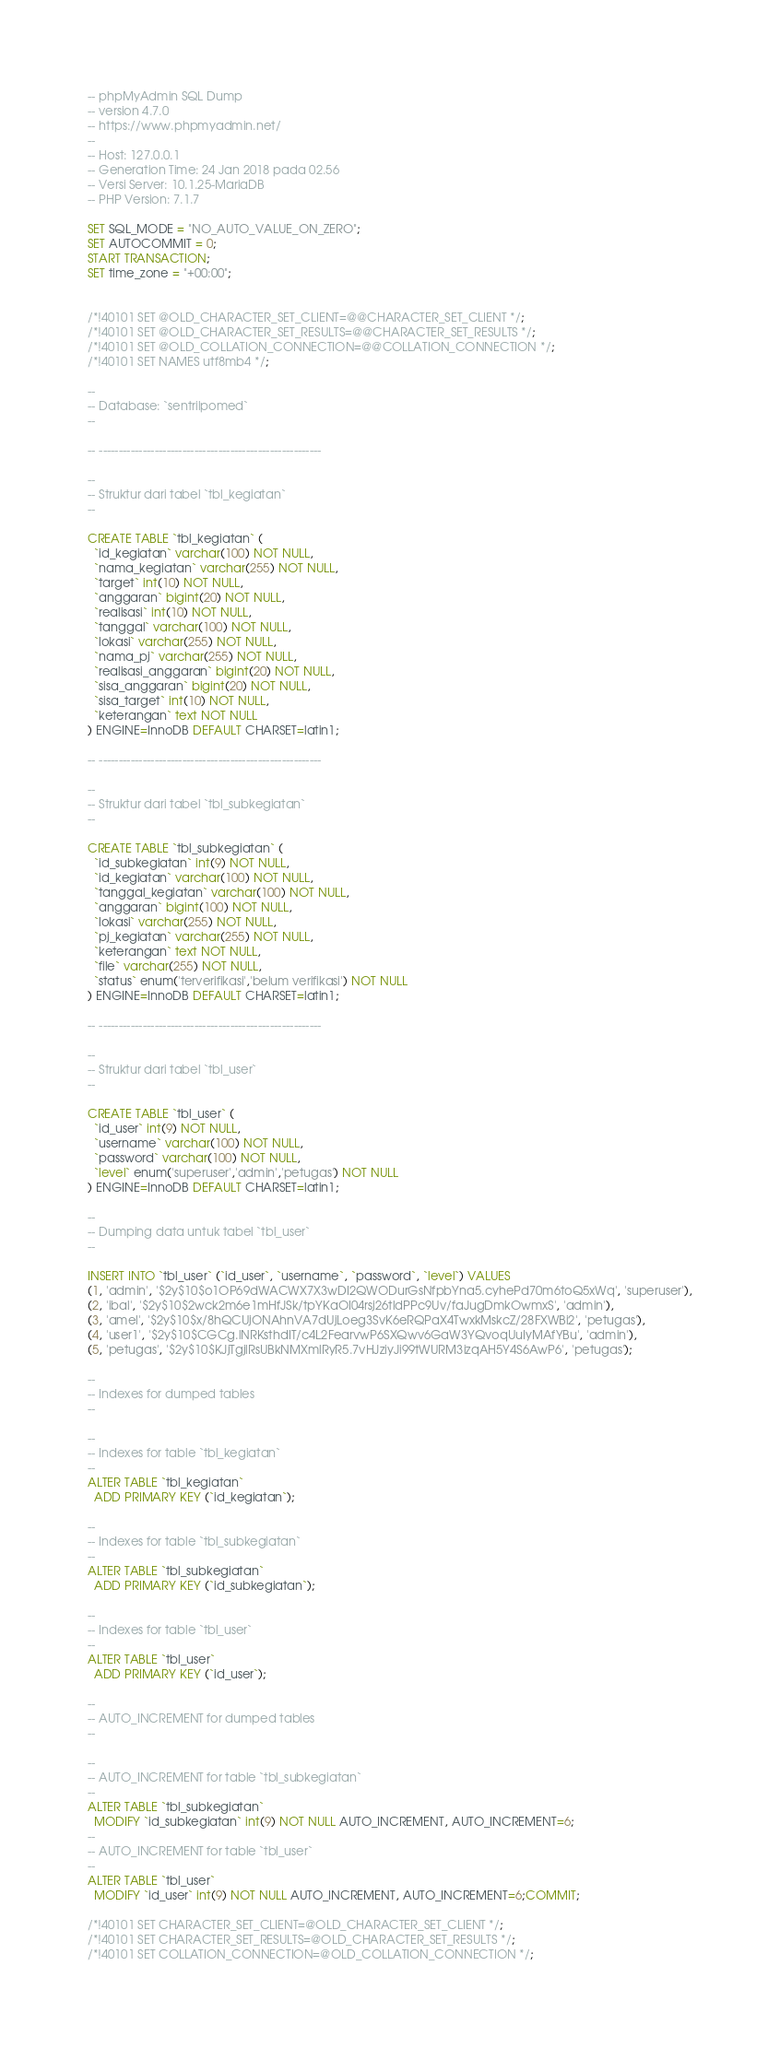Convert code to text. <code><loc_0><loc_0><loc_500><loc_500><_SQL_>-- phpMyAdmin SQL Dump
-- version 4.7.0
-- https://www.phpmyadmin.net/
--
-- Host: 127.0.0.1
-- Generation Time: 24 Jan 2018 pada 02.56
-- Versi Server: 10.1.25-MariaDB
-- PHP Version: 7.1.7

SET SQL_MODE = "NO_AUTO_VALUE_ON_ZERO";
SET AUTOCOMMIT = 0;
START TRANSACTION;
SET time_zone = "+00:00";


/*!40101 SET @OLD_CHARACTER_SET_CLIENT=@@CHARACTER_SET_CLIENT */;
/*!40101 SET @OLD_CHARACTER_SET_RESULTS=@@CHARACTER_SET_RESULTS */;
/*!40101 SET @OLD_COLLATION_CONNECTION=@@COLLATION_CONNECTION */;
/*!40101 SET NAMES utf8mb4 */;

--
-- Database: `sentrilpomed`
--

-- --------------------------------------------------------

--
-- Struktur dari tabel `tbl_kegiatan`
--

CREATE TABLE `tbl_kegiatan` (
  `id_kegiatan` varchar(100) NOT NULL,
  `nama_kegiatan` varchar(255) NOT NULL,
  `target` int(10) NOT NULL,
  `anggaran` bigint(20) NOT NULL,
  `realisasi` int(10) NOT NULL,
  `tanggal` varchar(100) NOT NULL,
  `lokasi` varchar(255) NOT NULL,
  `nama_pj` varchar(255) NOT NULL,
  `realisasi_anggaran` bigint(20) NOT NULL,
  `sisa_anggaran` bigint(20) NOT NULL,
  `sisa_target` int(10) NOT NULL,
  `keterangan` text NOT NULL
) ENGINE=InnoDB DEFAULT CHARSET=latin1;

-- --------------------------------------------------------

--
-- Struktur dari tabel `tbl_subkegiatan`
--

CREATE TABLE `tbl_subkegiatan` (
  `id_subkegiatan` int(9) NOT NULL,
  `id_kegiatan` varchar(100) NOT NULL,
  `tanggal_kegiatan` varchar(100) NOT NULL,
  `anggaran` bigint(100) NOT NULL,
  `lokasi` varchar(255) NOT NULL,
  `pj_kegiatan` varchar(255) NOT NULL,
  `keterangan` text NOT NULL,
  `file` varchar(255) NOT NULL,
  `status` enum('terverifikasi','belum verifikasi') NOT NULL
) ENGINE=InnoDB DEFAULT CHARSET=latin1;

-- --------------------------------------------------------

--
-- Struktur dari tabel `tbl_user`
--

CREATE TABLE `tbl_user` (
  `id_user` int(9) NOT NULL,
  `username` varchar(100) NOT NULL,
  `password` varchar(100) NOT NULL,
  `level` enum('superuser','admin','petugas') NOT NULL
) ENGINE=InnoDB DEFAULT CHARSET=latin1;

--
-- Dumping data untuk tabel `tbl_user`
--

INSERT INTO `tbl_user` (`id_user`, `username`, `password`, `level`) VALUES
(1, 'admin', '$2y$10$o1OP69dWACWX7X3wDI2QWODurGsNfpbYna5.cyhePd70m6toQ5xWq', 'superuser'),
(2, 'ibal', '$2y$10$2wck2m6e1mHfJSk/tpYKaOI04rsj26tldPPc9Uv/faJugDmkOwmxS', 'admin'),
(3, 'amel', '$2y$10$x/8hQCUjONAhnVA7dUjLoeg3SvK6eRQPaX4TwxkMskcZ/28FXWBi2', 'petugas'),
(4, 'user1', '$2y$10$CGCg.lNRKsthdIT/c4L2FearvwP6SXQwv6GaW3YQvoqUuIyMAfYBu', 'admin'),
(5, 'petugas', '$2y$10$KJjTgjlRsUBkNMXmlRyR5.7vHJziyJi99tWURM3izqAH5Y4S6AwP6', 'petugas');

--
-- Indexes for dumped tables
--

--
-- Indexes for table `tbl_kegiatan`
--
ALTER TABLE `tbl_kegiatan`
  ADD PRIMARY KEY (`id_kegiatan`);

--
-- Indexes for table `tbl_subkegiatan`
--
ALTER TABLE `tbl_subkegiatan`
  ADD PRIMARY KEY (`id_subkegiatan`);

--
-- Indexes for table `tbl_user`
--
ALTER TABLE `tbl_user`
  ADD PRIMARY KEY (`id_user`);

--
-- AUTO_INCREMENT for dumped tables
--

--
-- AUTO_INCREMENT for table `tbl_subkegiatan`
--
ALTER TABLE `tbl_subkegiatan`
  MODIFY `id_subkegiatan` int(9) NOT NULL AUTO_INCREMENT, AUTO_INCREMENT=6;
--
-- AUTO_INCREMENT for table `tbl_user`
--
ALTER TABLE `tbl_user`
  MODIFY `id_user` int(9) NOT NULL AUTO_INCREMENT, AUTO_INCREMENT=6;COMMIT;

/*!40101 SET CHARACTER_SET_CLIENT=@OLD_CHARACTER_SET_CLIENT */;
/*!40101 SET CHARACTER_SET_RESULTS=@OLD_CHARACTER_SET_RESULTS */;
/*!40101 SET COLLATION_CONNECTION=@OLD_COLLATION_CONNECTION */;
</code> 